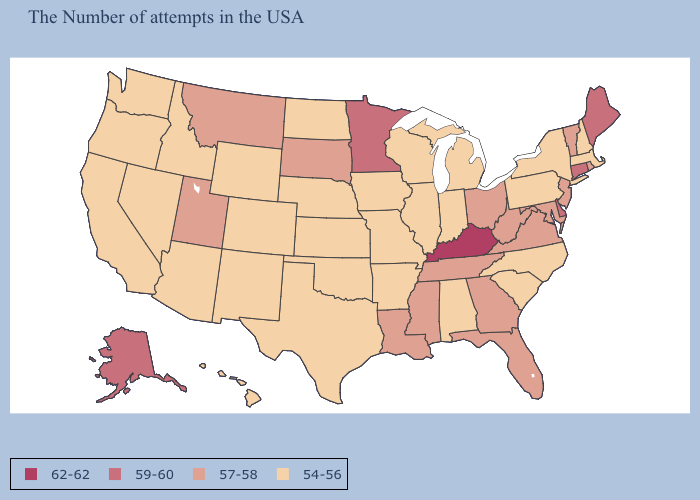Does the first symbol in the legend represent the smallest category?
Concise answer only. No. Does Indiana have a lower value than Alabama?
Short answer required. No. What is the value of Texas?
Answer briefly. 54-56. Which states have the highest value in the USA?
Write a very short answer. Kentucky. Name the states that have a value in the range 54-56?
Answer briefly. Massachusetts, New Hampshire, New York, Pennsylvania, North Carolina, South Carolina, Michigan, Indiana, Alabama, Wisconsin, Illinois, Missouri, Arkansas, Iowa, Kansas, Nebraska, Oklahoma, Texas, North Dakota, Wyoming, Colorado, New Mexico, Arizona, Idaho, Nevada, California, Washington, Oregon, Hawaii. Name the states that have a value in the range 54-56?
Write a very short answer. Massachusetts, New Hampshire, New York, Pennsylvania, North Carolina, South Carolina, Michigan, Indiana, Alabama, Wisconsin, Illinois, Missouri, Arkansas, Iowa, Kansas, Nebraska, Oklahoma, Texas, North Dakota, Wyoming, Colorado, New Mexico, Arizona, Idaho, Nevada, California, Washington, Oregon, Hawaii. Does the map have missing data?
Quick response, please. No. Which states hav the highest value in the Northeast?
Keep it brief. Maine, Connecticut. Does Montana have the lowest value in the West?
Be succinct. No. Does Virginia have the lowest value in the South?
Answer briefly. No. Does North Dakota have the same value as Hawaii?
Write a very short answer. Yes. What is the highest value in the USA?
Answer briefly. 62-62. Among the states that border Connecticut , which have the highest value?
Quick response, please. Rhode Island. How many symbols are there in the legend?
Answer briefly. 4. Which states hav the highest value in the South?
Write a very short answer. Kentucky. 